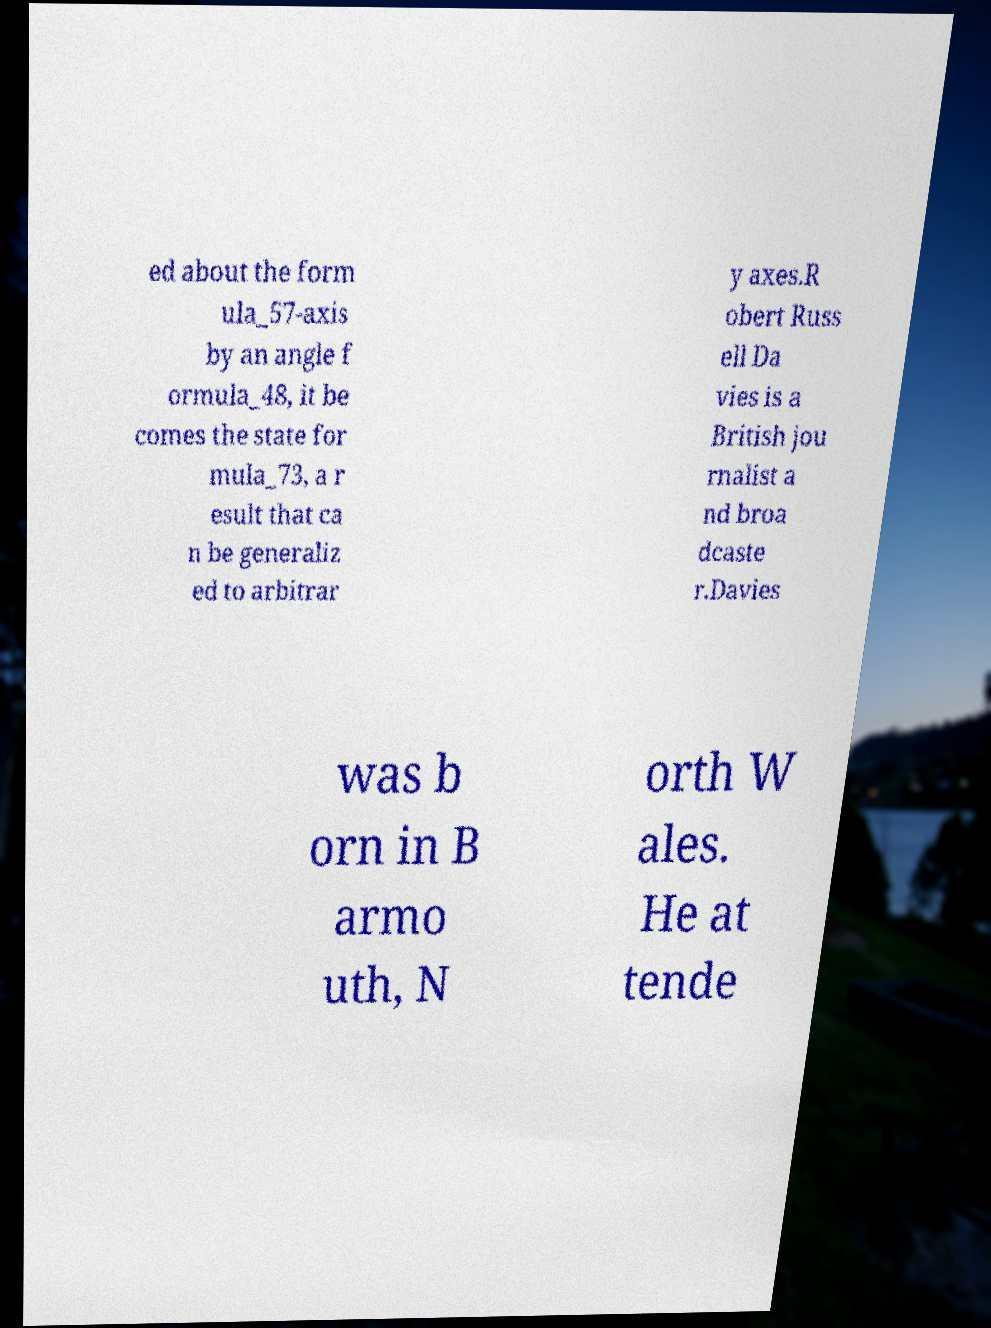I need the written content from this picture converted into text. Can you do that? ed about the form ula_57-axis by an angle f ormula_48, it be comes the state for mula_73, a r esult that ca n be generaliz ed to arbitrar y axes.R obert Russ ell Da vies is a British jou rnalist a nd broa dcaste r.Davies was b orn in B armo uth, N orth W ales. He at tende 